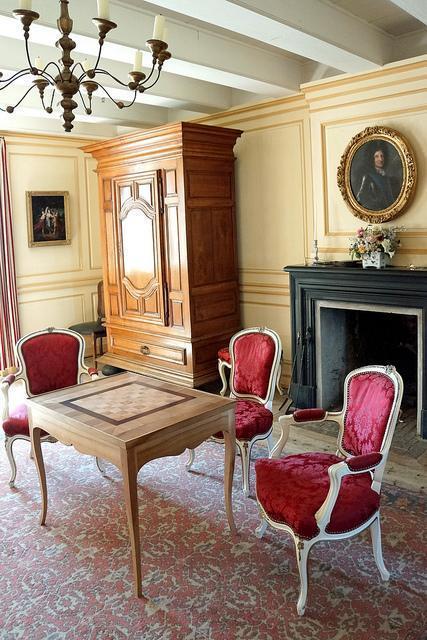How many red chairs are in the room?
Give a very brief answer. 3. How many chairs are there?
Give a very brief answer. 3. How many elephants are there?
Give a very brief answer. 0. 